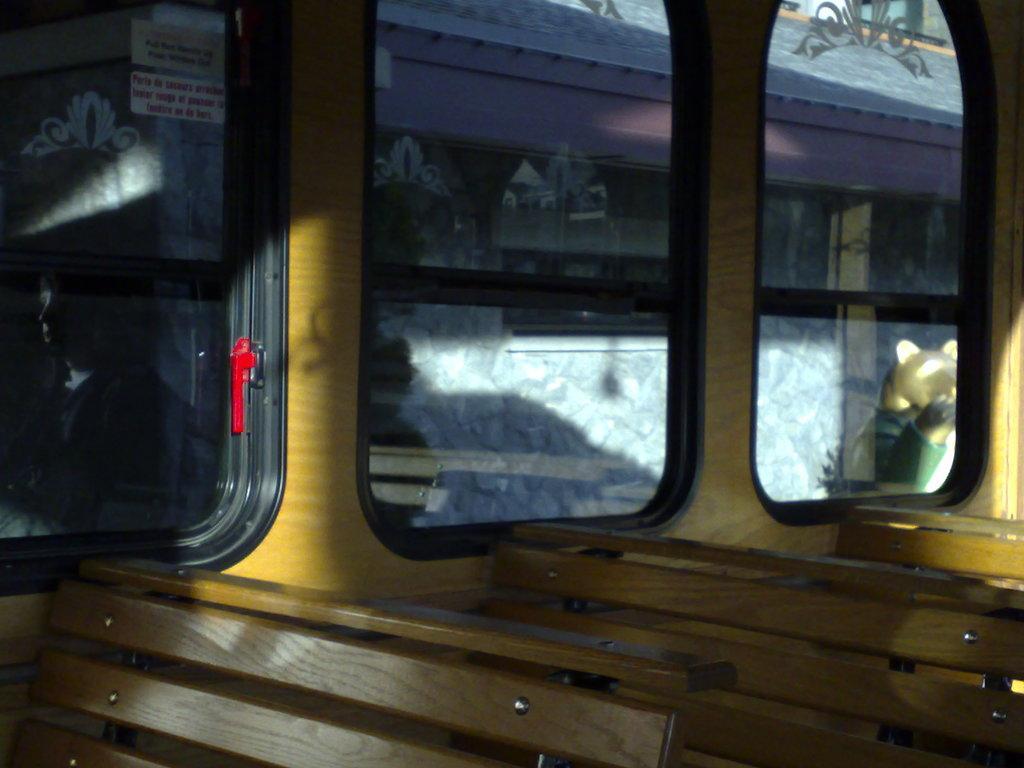How would you summarize this image in a sentence or two? In this picture we can see an inside view of a bus, there are three benches here, we can see glasses, from the glass we can see a building. 